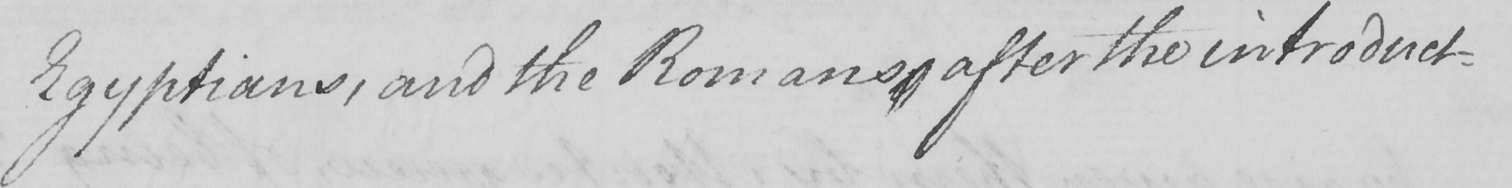What text is written in this handwritten line? Egyptians , and the Romans , after the introduct- 